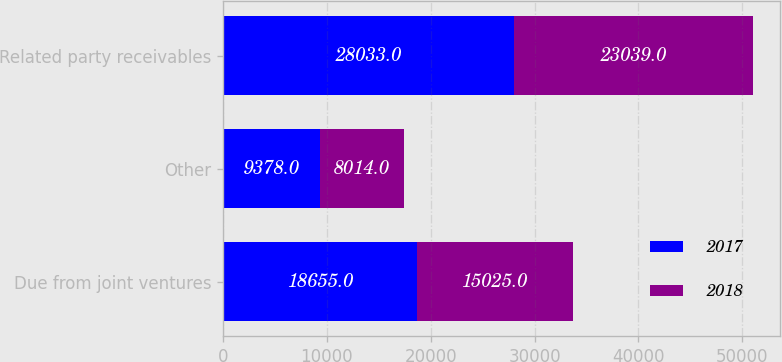Convert chart. <chart><loc_0><loc_0><loc_500><loc_500><stacked_bar_chart><ecel><fcel>Due from joint ventures<fcel>Other<fcel>Related party receivables<nl><fcel>2017<fcel>18655<fcel>9378<fcel>28033<nl><fcel>2018<fcel>15025<fcel>8014<fcel>23039<nl></chart> 